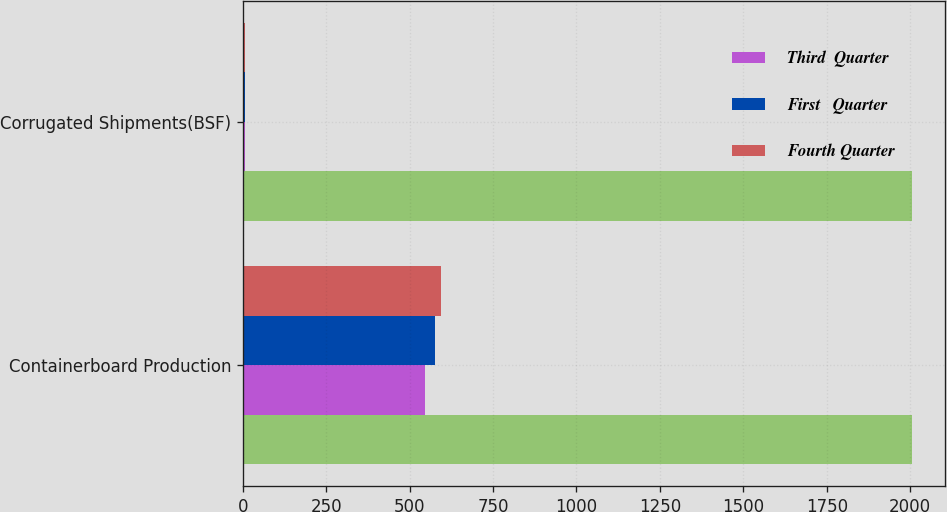Convert chart to OTSL. <chart><loc_0><loc_0><loc_500><loc_500><stacked_bar_chart><ecel><fcel>Containerboard Production<fcel>Corrugated Shipments(BSF)<nl><fcel>nan<fcel>2004<fcel>2004<nl><fcel>Third  Quarter<fcel>547<fcel>7.2<nl><fcel>First   Quarter<fcel>577<fcel>7.7<nl><fcel>Fourth Quarter<fcel>595<fcel>7.6<nl></chart> 